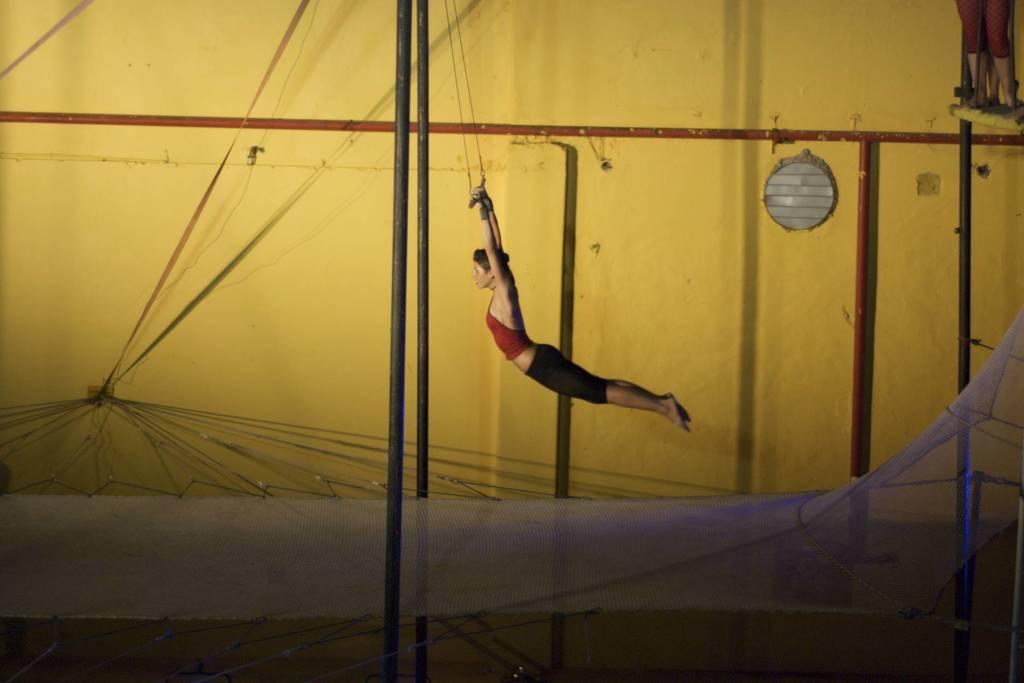Could you give a brief overview of what you see in this image? In this image we can see a woman doing the exercise. At the bottom we can see the net. In the background we can see the wall and some rods. 